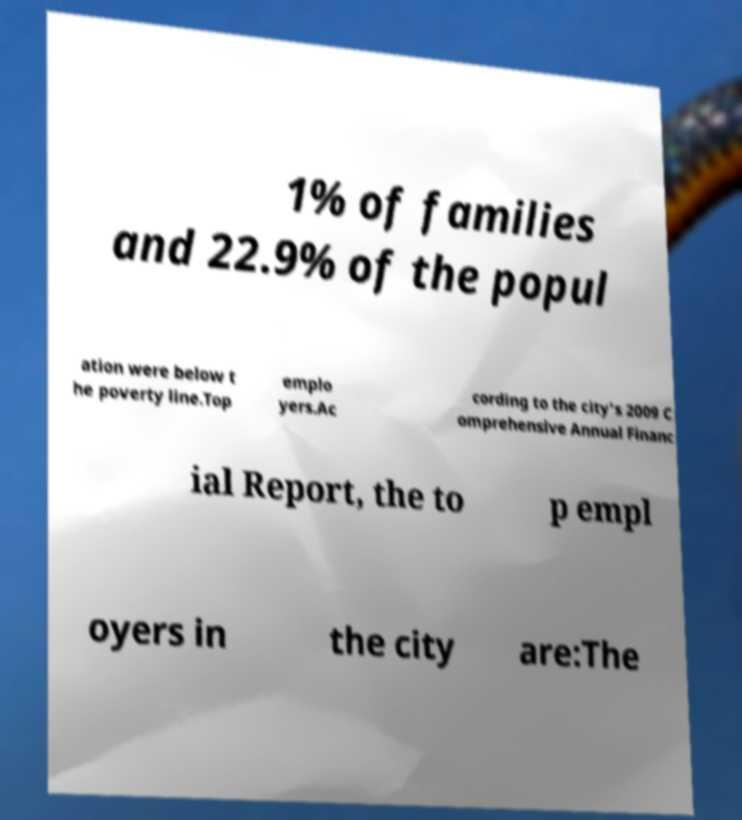For documentation purposes, I need the text within this image transcribed. Could you provide that? 1% of families and 22.9% of the popul ation were below t he poverty line.Top emplo yers.Ac cording to the city's 2009 C omprehensive Annual Financ ial Report, the to p empl oyers in the city are:The 